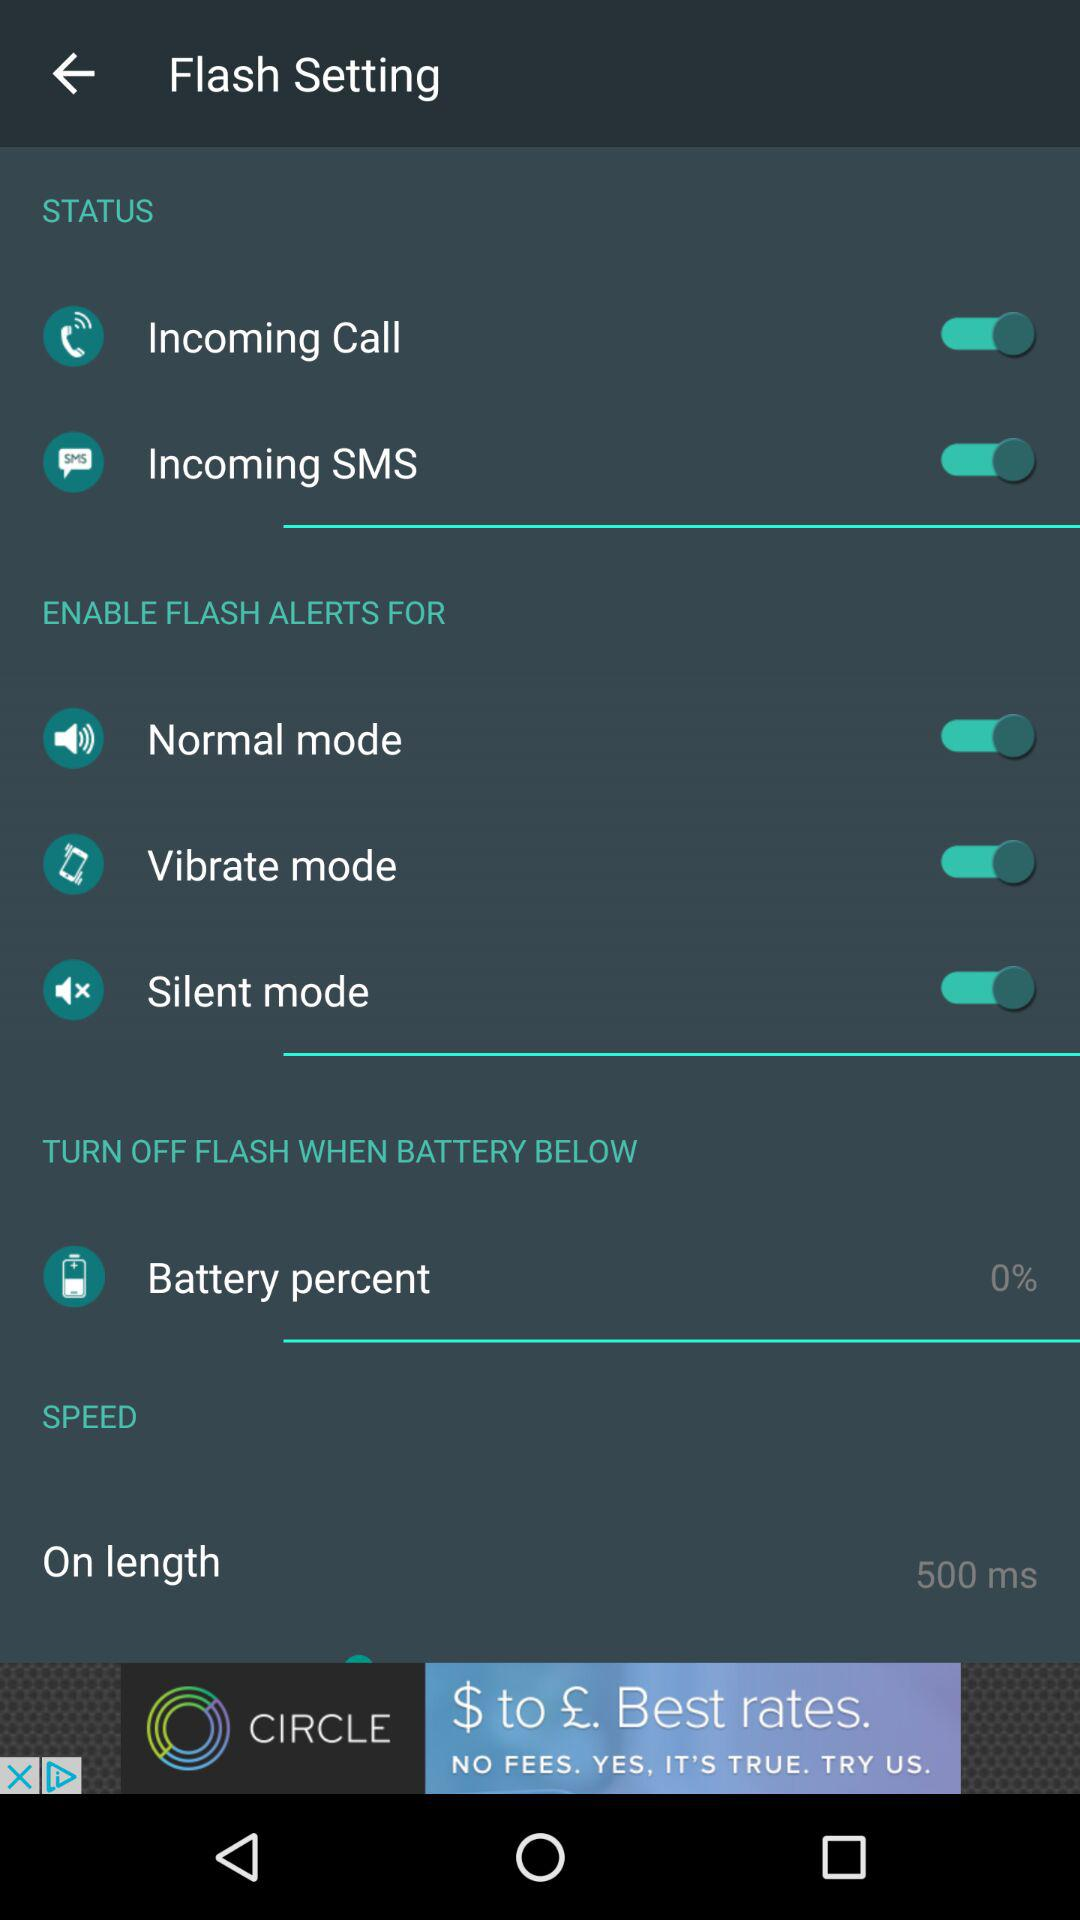What's the status of "Incoming SMS"? The status of "Incoming SMS" is "on". 